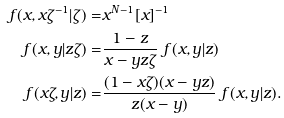<formula> <loc_0><loc_0><loc_500><loc_500>f ( x , x \zeta ^ { - 1 } | \zeta ) = & x ^ { N - 1 } [ x ] ^ { - 1 } \\ f ( x , y | z \zeta ) = & \frac { 1 - z } { x - y z \zeta } \ f ( x , y | z ) \\ f ( x \zeta , y | z ) = & \frac { ( 1 - x \zeta ) ( x - y z ) } { z ( x - y ) } \ f ( x , y | z ) .</formula> 